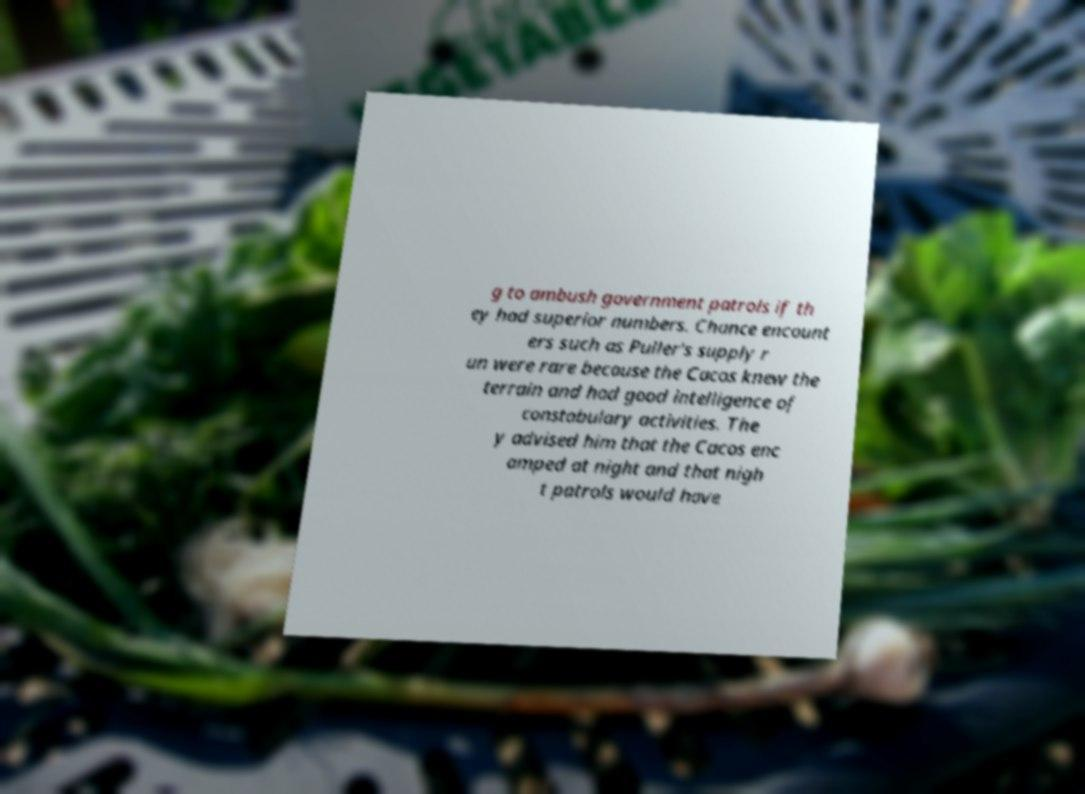Please read and relay the text visible in this image. What does it say? g to ambush government patrols if th ey had superior numbers. Chance encount ers such as Puller's supply r un were rare because the Cacos knew the terrain and had good intelligence of constabulary activities. The y advised him that the Cacos enc amped at night and that nigh t patrols would have 